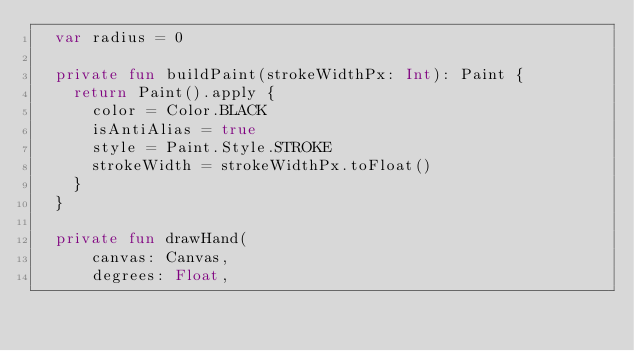Convert code to text. <code><loc_0><loc_0><loc_500><loc_500><_Kotlin_>  var radius = 0

  private fun buildPaint(strokeWidthPx: Int): Paint {
    return Paint().apply {
      color = Color.BLACK
      isAntiAlias = true
      style = Paint.Style.STROKE
      strokeWidth = strokeWidthPx.toFloat()
    }
  }

  private fun drawHand(
      canvas: Canvas,
      degrees: Float,</code> 